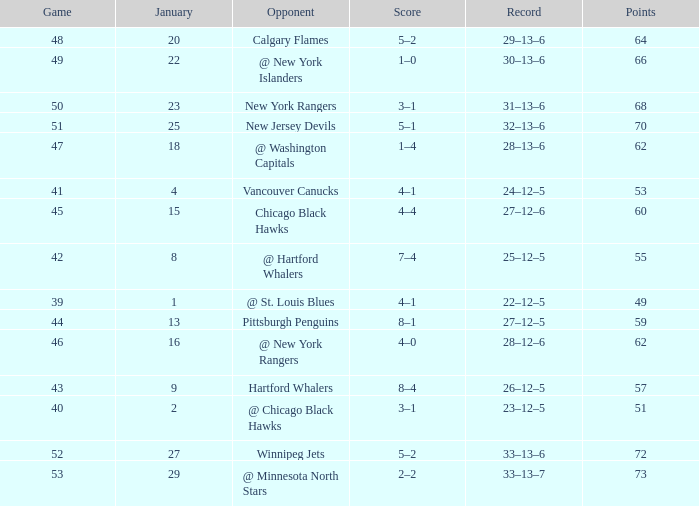Which Points have a Score of 4–1, and a Game smaller than 39? None. 